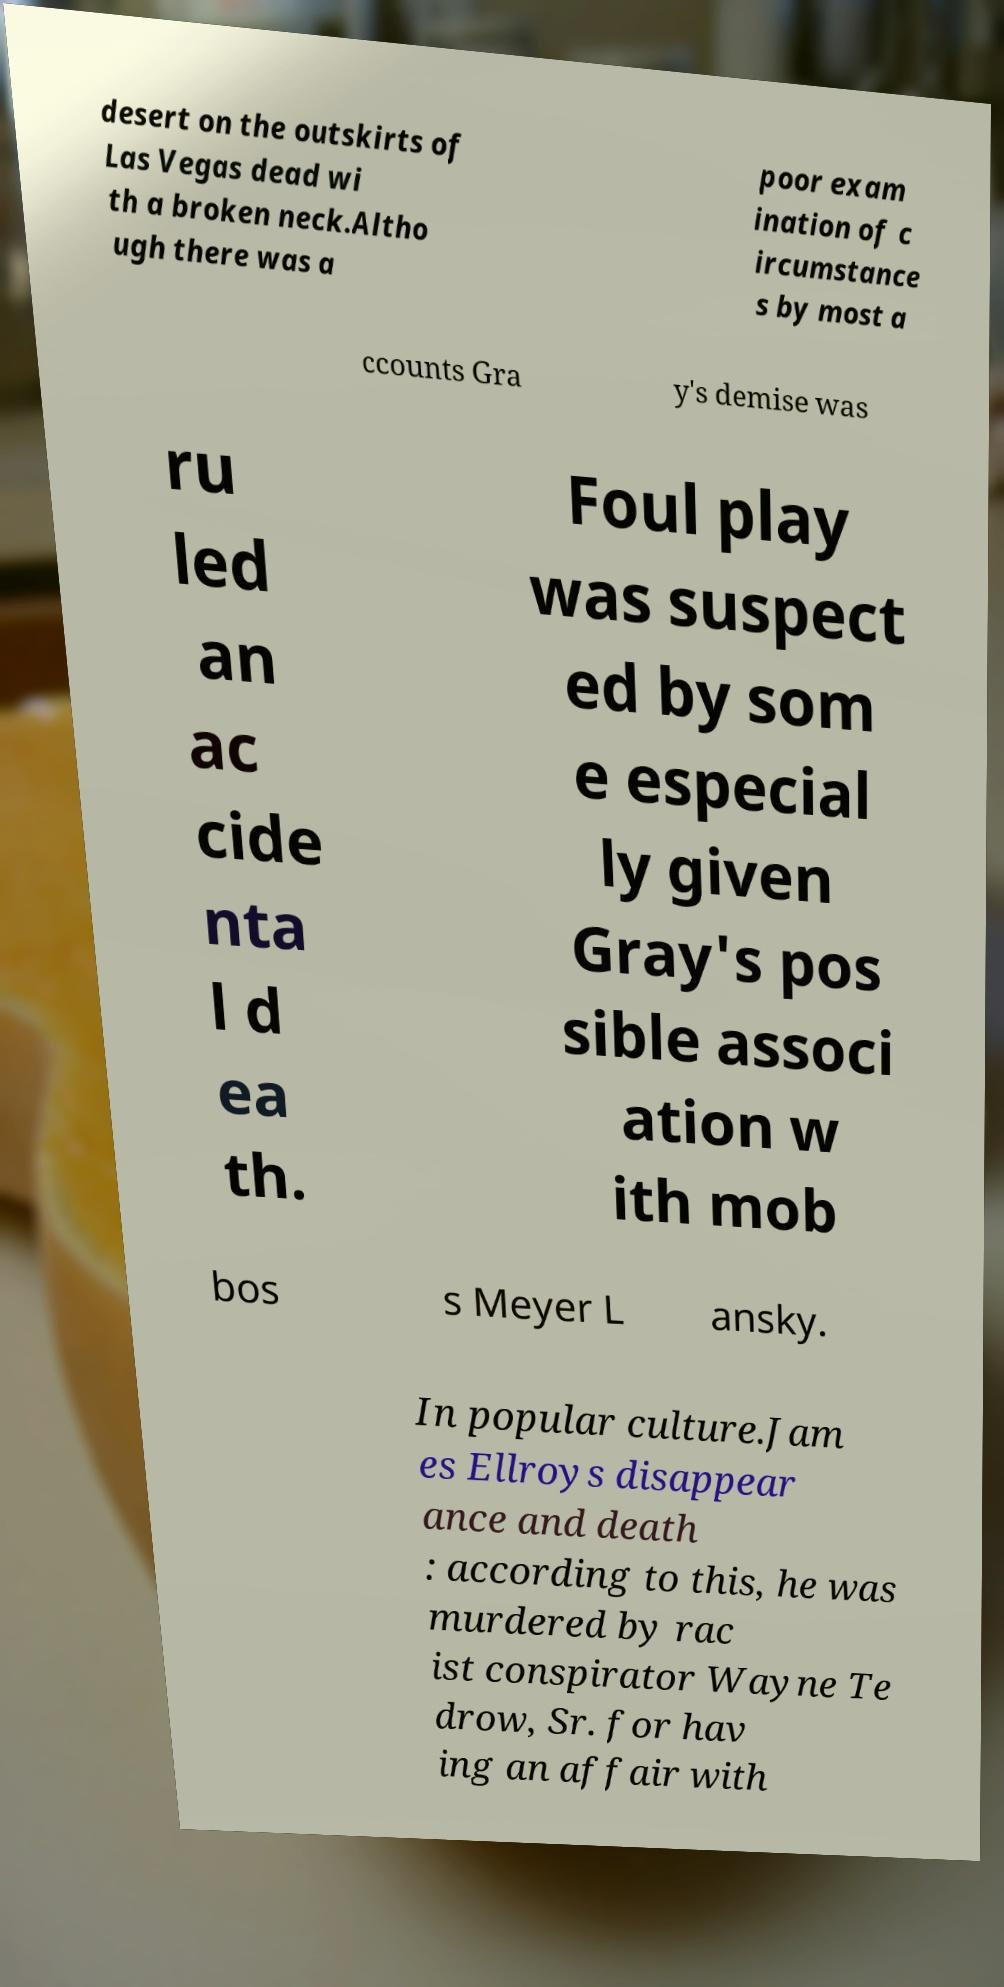Could you assist in decoding the text presented in this image and type it out clearly? desert on the outskirts of Las Vegas dead wi th a broken neck.Altho ugh there was a poor exam ination of c ircumstance s by most a ccounts Gra y's demise was ru led an ac cide nta l d ea th. Foul play was suspect ed by som e especial ly given Gray's pos sible associ ation w ith mob bos s Meyer L ansky. In popular culture.Jam es Ellroys disappear ance and death : according to this, he was murdered by rac ist conspirator Wayne Te drow, Sr. for hav ing an affair with 